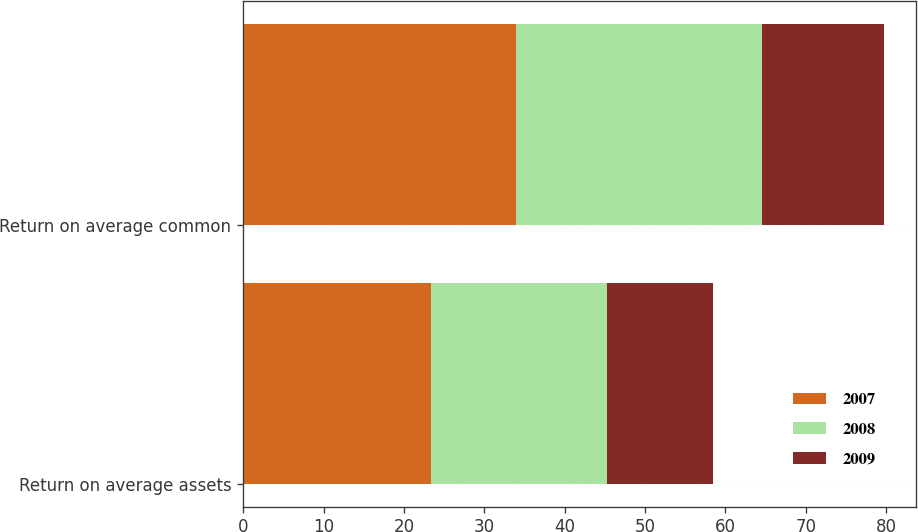<chart> <loc_0><loc_0><loc_500><loc_500><stacked_bar_chart><ecel><fcel>Return on average assets<fcel>Return on average common<nl><fcel>2007<fcel>23.4<fcel>34<nl><fcel>2008<fcel>21.8<fcel>30.6<nl><fcel>2009<fcel>13.2<fcel>15.1<nl></chart> 